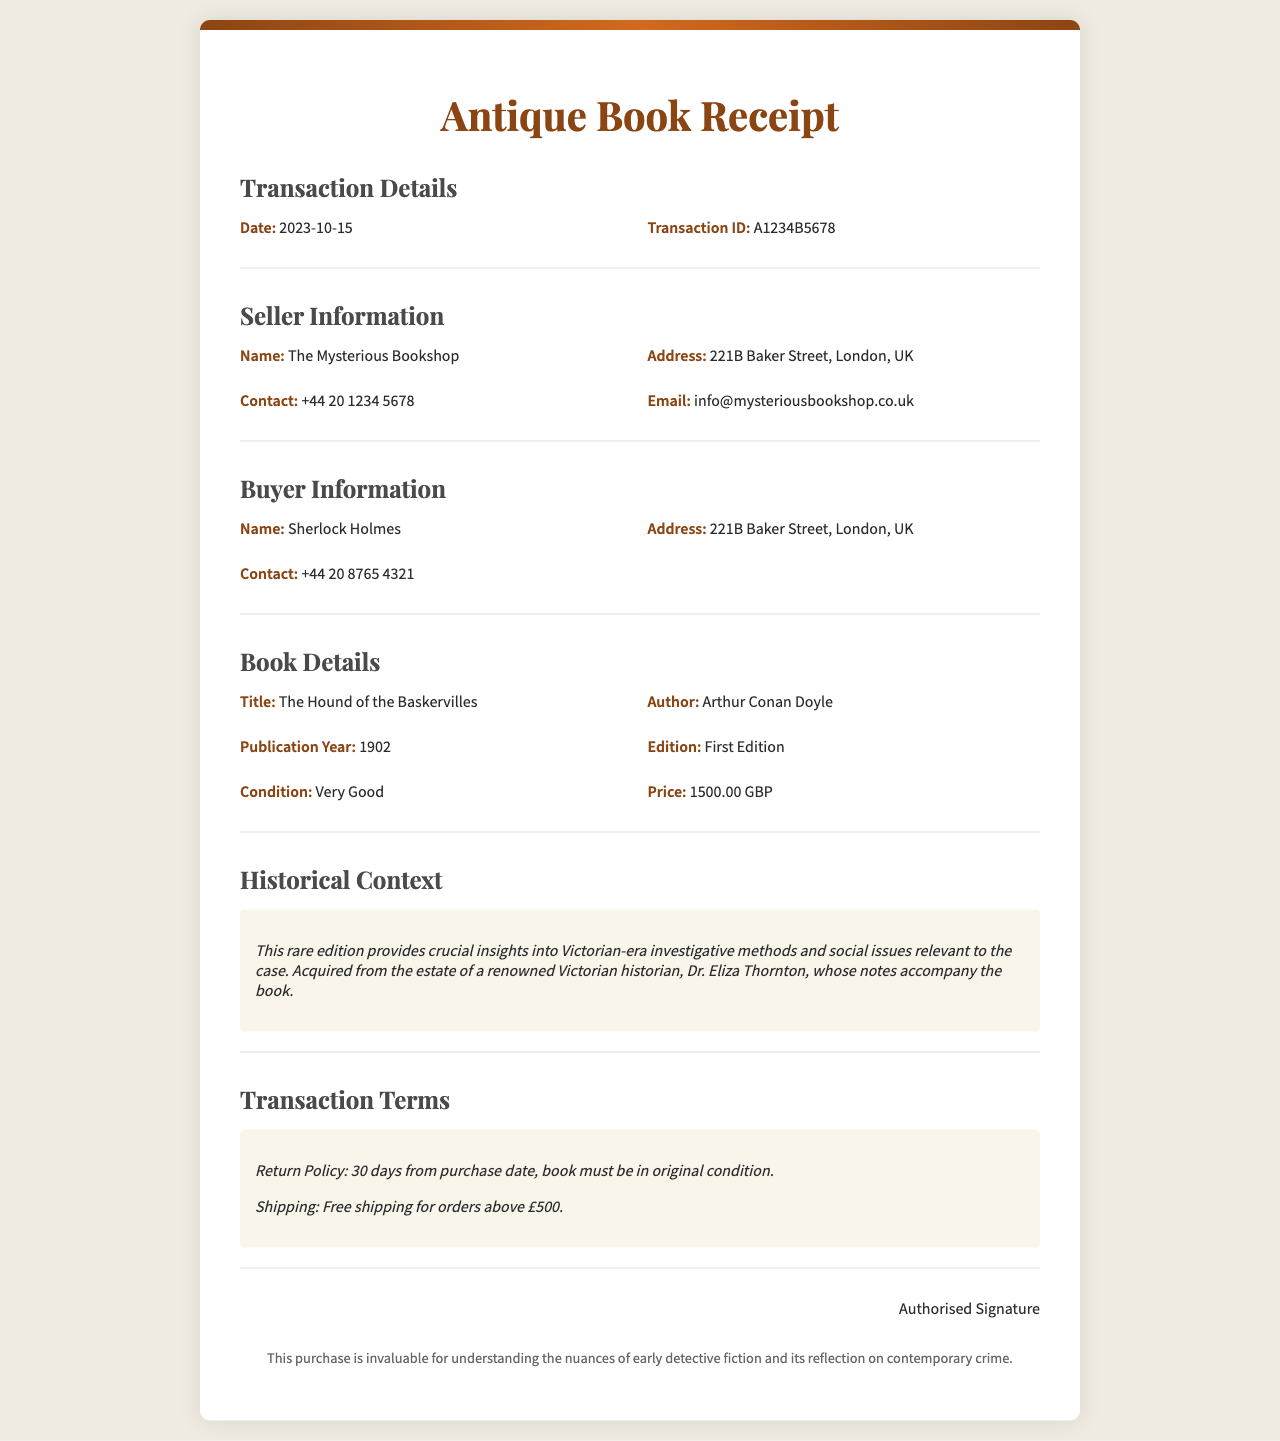What is the transaction date? The transaction date is listed in the document under "Transaction Details."
Answer: 2023-10-15 Who is the seller? The seller's name is found in the "Seller Information" section.
Answer: The Mysterious Bookshop What is the title of the book? The title of the book is specified in the "Book Details" section.
Answer: The Hound of the Baskervilles What is the price of the book? The price can be located in the "Book Details" section as well.
Answer: 1500.00 GBP What is the publication year of the book? The publication year is stated in the "Book Details" section.
Answer: 1902 What does the historical context reveal? The historical context section provides insights into the relevance of the book related to a cold case investigation.
Answer: Victorian-era investigative methods What is the return policy? The return policy is included in the "Transaction Terms" section of the document.
Answer: 30 days from purchase date Who was the book acquired from? The document mentions the previous owner of the book in the historical context.
Answer: Dr. Eliza Thornton What condition is the book in? This information can be found in the "Book Details" section.
Answer: Very Good 